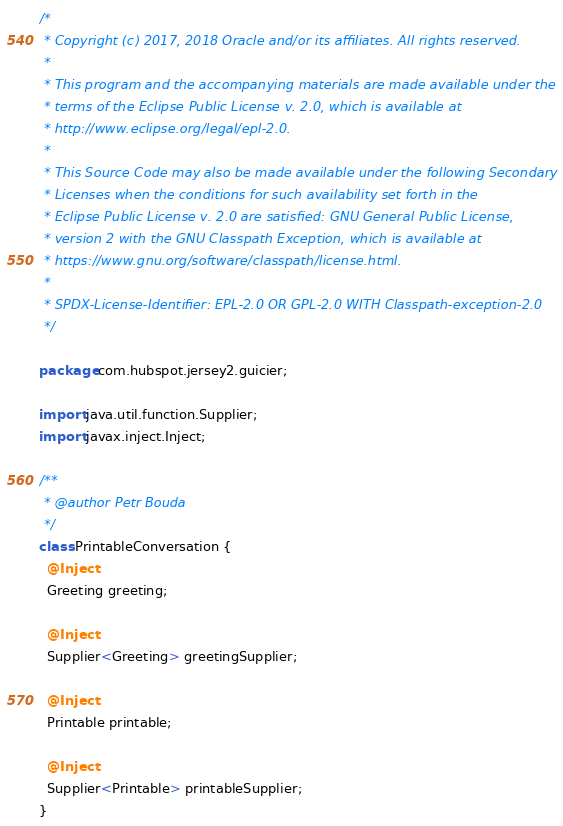<code> <loc_0><loc_0><loc_500><loc_500><_Java_>/*
 * Copyright (c) 2017, 2018 Oracle and/or its affiliates. All rights reserved.
 *
 * This program and the accompanying materials are made available under the
 * terms of the Eclipse Public License v. 2.0, which is available at
 * http://www.eclipse.org/legal/epl-2.0.
 *
 * This Source Code may also be made available under the following Secondary
 * Licenses when the conditions for such availability set forth in the
 * Eclipse Public License v. 2.0 are satisfied: GNU General Public License,
 * version 2 with the GNU Classpath Exception, which is available at
 * https://www.gnu.org/software/classpath/license.html.
 *
 * SPDX-License-Identifier: EPL-2.0 OR GPL-2.0 WITH Classpath-exception-2.0
 */

package com.hubspot.jersey2.guicier;

import java.util.function.Supplier;
import javax.inject.Inject;

/**
 * @author Petr Bouda
 */
class PrintableConversation {
  @Inject
  Greeting greeting;

  @Inject
  Supplier<Greeting> greetingSupplier;

  @Inject
  Printable printable;

  @Inject
  Supplier<Printable> printableSupplier;
}
</code> 